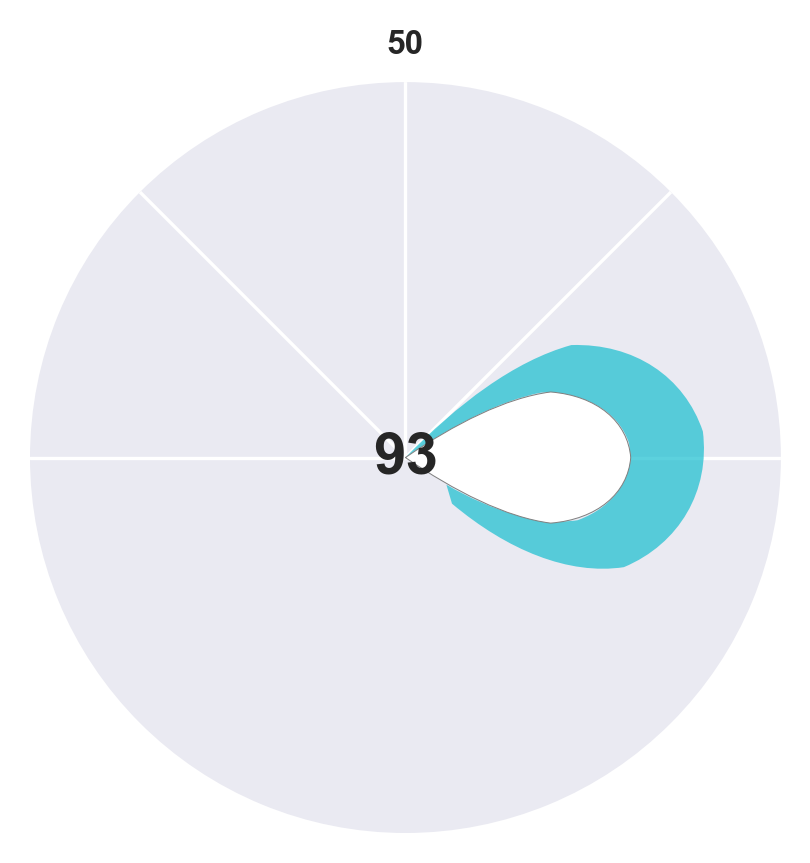what is the title of the figure? The title of the figure is often placed at the top and gives a summary of what the figure represents. Here, it is "Team Productivity and Work-Life Balance Scores".
Answer: Team Productivity and Work-Life Balance Scores In which team is the work-life balance score higher than the productivity score by the largest margin? By examining the differential between productivity and work-life balance scores for each team, the Product Development team shows the largest margin with scores of 88 for productivity and 95 for work-life balance.
Answer: Product Development Which team has the highest productivity score? The highest productivity score can be identified by comparing the productivity scores of all the teams. Research & Development team has the highest productivity score of 90.
Answer: Research & Development What is the average productivity score across all teams? Sum the productivity scores for all teams (78 + 82 + 75 + 88 + 80 + 76 + 85 + 90), which equals 654. Divide by the number of teams (8) to get the average. So, 654/8 = 81.75.
Answer: 81.75 Which team's productivity score is closest to its work-life balance score? We need to look for the smallest difference between the productivity and work-life balance scores for each team. The Operations team has scores of 85 and 88, which gives a difference of 3, the smallest of all.
Answer: Operations Is there a team where the work-life balance score is lower than the productivity score? By comparing the productivity and work-life balance scores for each team, we can see that for all teams, the work-life balance score is higher than the productivity score.
Answer: No What is the difference between the highest work-life balance score and the lowest productivity score? Identify the highest work-life balance score, which is 95 for Product Development, and the lowest productivity score, which is 75 for Customer Support. Calculate the difference: 95 - 75 = 20.
Answer: 20 Which two teams have the highest similarity in their work-life balance scores? We look for the smallest difference in the work-life balance scores between all pairs of teams. Human Resources has a score of 92 and Research & Development has 93, resulting in the smallest difference of 1.
Answer: Human Resources and Research & Development 